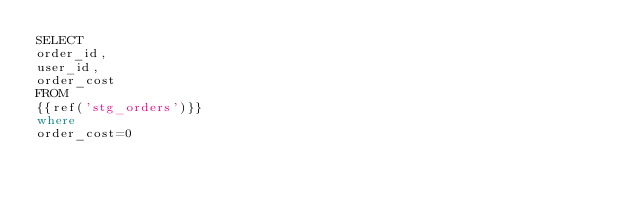<code> <loc_0><loc_0><loc_500><loc_500><_SQL_>SELECT
order_id,
user_id,
order_cost
FROM
{{ref('stg_orders')}}
where 
order_cost=0</code> 